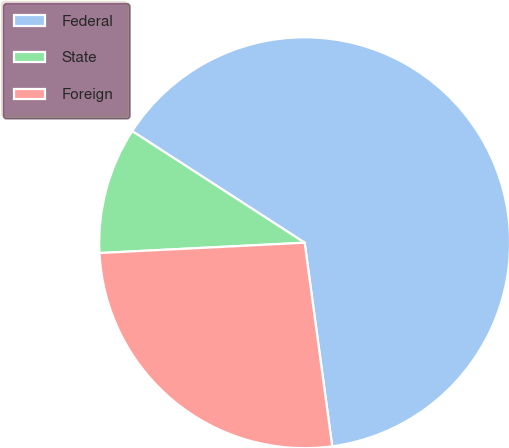Convert chart. <chart><loc_0><loc_0><loc_500><loc_500><pie_chart><fcel>Federal<fcel>State<fcel>Foreign<nl><fcel>63.71%<fcel>9.94%<fcel>26.34%<nl></chart> 